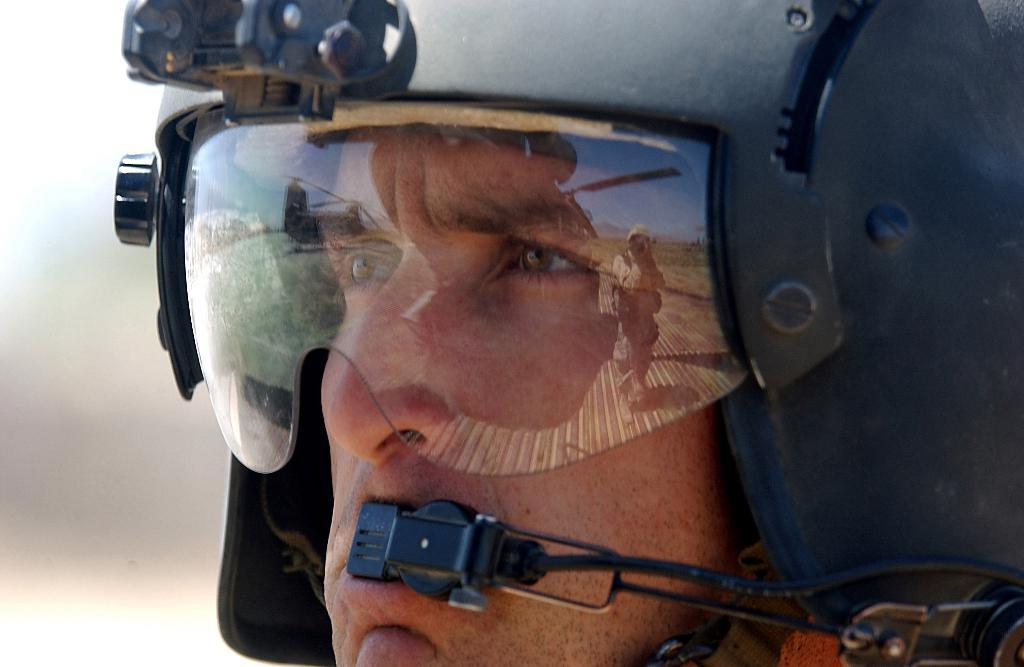What is the main subject in the foreground of the image? There is a person in the foreground of the image. What is the person wearing in the image? The person is wearing a helmet in the image. Can you describe the background of the image? The background of the image is blurred. What type of yoke is the person using to carry the tree in the image? There is no tree or yoke present in the image; the person is wearing a helmet and the background is blurred. 